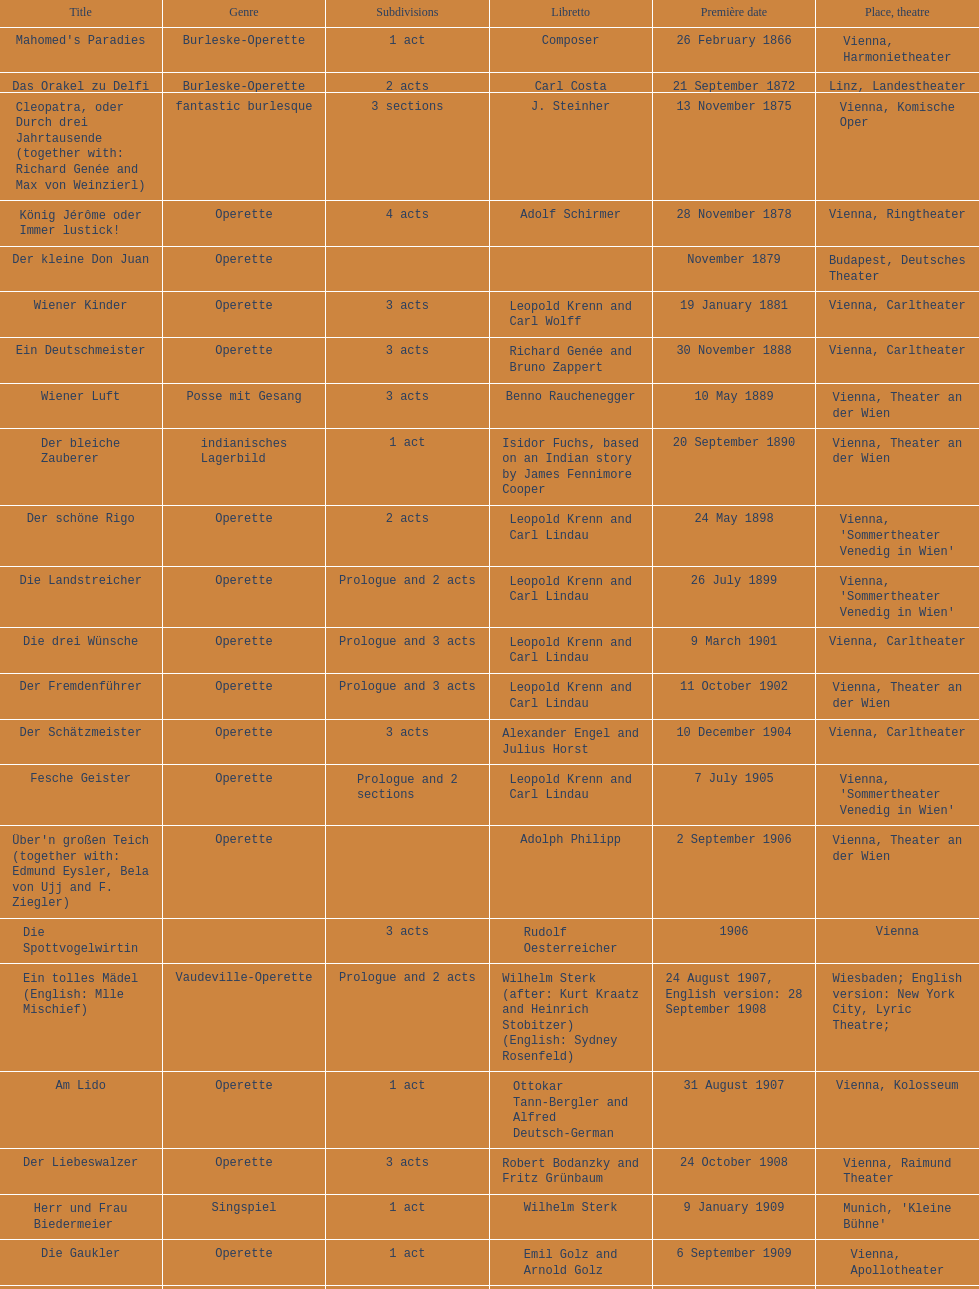In what year did he launch his final operetta? 1930. 